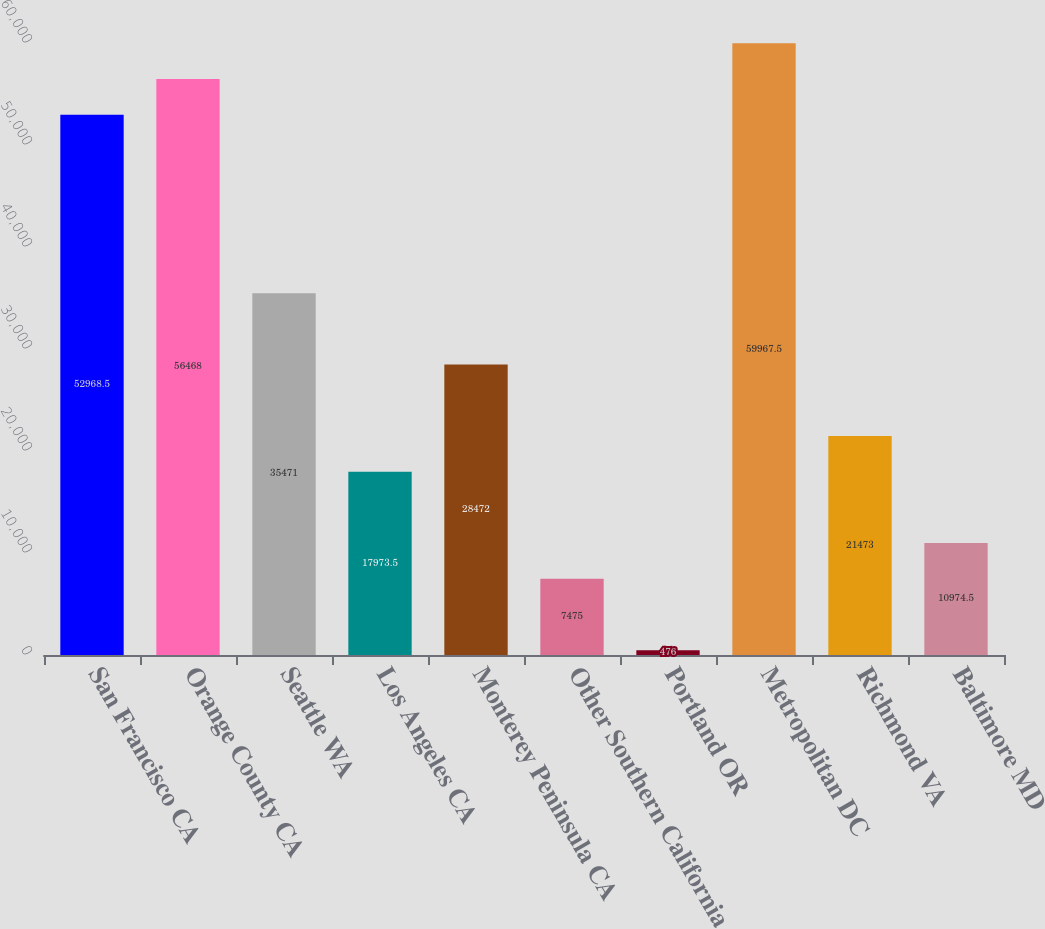Convert chart to OTSL. <chart><loc_0><loc_0><loc_500><loc_500><bar_chart><fcel>San Francisco CA<fcel>Orange County CA<fcel>Seattle WA<fcel>Los Angeles CA<fcel>Monterey Peninsula CA<fcel>Other Southern California<fcel>Portland OR<fcel>Metropolitan DC<fcel>Richmond VA<fcel>Baltimore MD<nl><fcel>52968.5<fcel>56468<fcel>35471<fcel>17973.5<fcel>28472<fcel>7475<fcel>476<fcel>59967.5<fcel>21473<fcel>10974.5<nl></chart> 